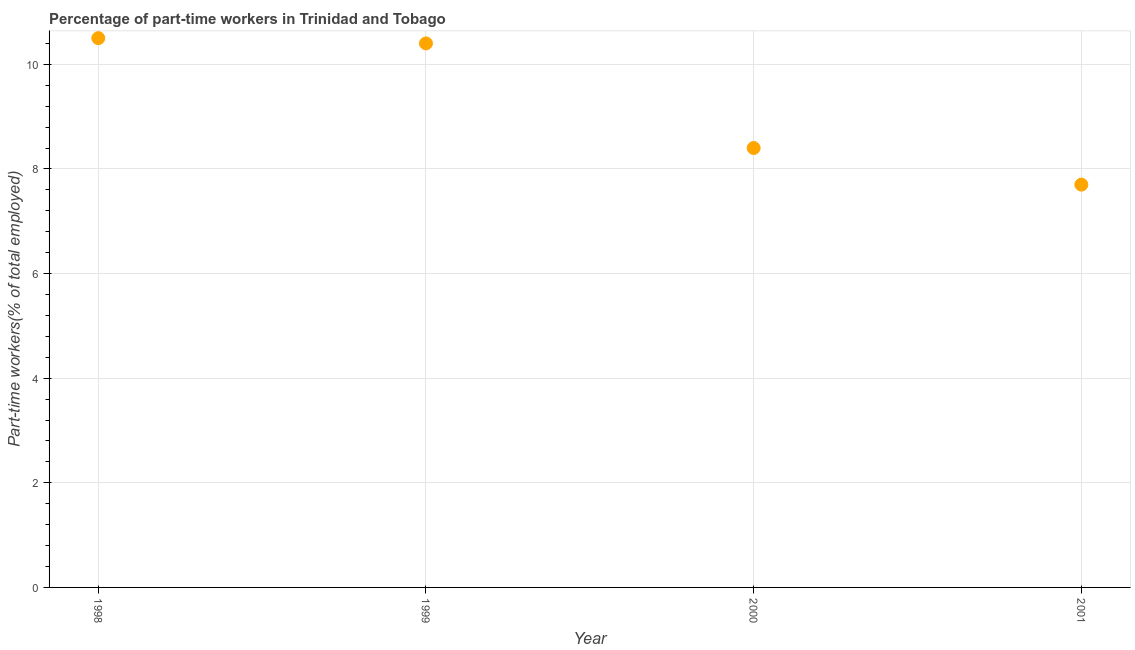What is the percentage of part-time workers in 2001?
Your answer should be very brief. 7.7. Across all years, what is the maximum percentage of part-time workers?
Offer a very short reply. 10.5. Across all years, what is the minimum percentage of part-time workers?
Offer a very short reply. 7.7. In which year was the percentage of part-time workers maximum?
Your response must be concise. 1998. What is the sum of the percentage of part-time workers?
Ensure brevity in your answer.  37. What is the difference between the percentage of part-time workers in 1998 and 1999?
Keep it short and to the point. 0.1. What is the average percentage of part-time workers per year?
Provide a short and direct response. 9.25. What is the median percentage of part-time workers?
Keep it short and to the point. 9.4. In how many years, is the percentage of part-time workers greater than 4.4 %?
Ensure brevity in your answer.  4. Do a majority of the years between 2000 and 1998 (inclusive) have percentage of part-time workers greater than 1.6 %?
Your response must be concise. No. What is the ratio of the percentage of part-time workers in 1998 to that in 2000?
Your response must be concise. 1.25. Is the percentage of part-time workers in 1999 less than that in 2001?
Your response must be concise. No. What is the difference between the highest and the second highest percentage of part-time workers?
Offer a very short reply. 0.1. What is the difference between the highest and the lowest percentage of part-time workers?
Provide a succinct answer. 2.8. What is the difference between two consecutive major ticks on the Y-axis?
Offer a very short reply. 2. What is the title of the graph?
Provide a short and direct response. Percentage of part-time workers in Trinidad and Tobago. What is the label or title of the Y-axis?
Offer a terse response. Part-time workers(% of total employed). What is the Part-time workers(% of total employed) in 1999?
Offer a terse response. 10.4. What is the Part-time workers(% of total employed) in 2000?
Provide a short and direct response. 8.4. What is the Part-time workers(% of total employed) in 2001?
Your response must be concise. 7.7. What is the difference between the Part-time workers(% of total employed) in 1998 and 2000?
Your response must be concise. 2.1. What is the difference between the Part-time workers(% of total employed) in 1998 and 2001?
Your answer should be very brief. 2.8. What is the difference between the Part-time workers(% of total employed) in 1999 and 2001?
Your answer should be very brief. 2.7. What is the difference between the Part-time workers(% of total employed) in 2000 and 2001?
Provide a short and direct response. 0.7. What is the ratio of the Part-time workers(% of total employed) in 1998 to that in 2000?
Ensure brevity in your answer.  1.25. What is the ratio of the Part-time workers(% of total employed) in 1998 to that in 2001?
Make the answer very short. 1.36. What is the ratio of the Part-time workers(% of total employed) in 1999 to that in 2000?
Provide a succinct answer. 1.24. What is the ratio of the Part-time workers(% of total employed) in 1999 to that in 2001?
Offer a very short reply. 1.35. What is the ratio of the Part-time workers(% of total employed) in 2000 to that in 2001?
Give a very brief answer. 1.09. 